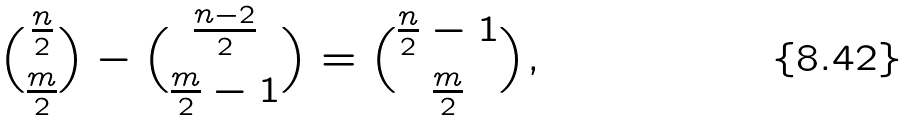<formula> <loc_0><loc_0><loc_500><loc_500>{ \frac { n } { 2 } \choose \frac { m } { 2 } } - { \frac { n - 2 } { 2 } \choose \frac { m } { 2 } - 1 } = { \frac { n } { 2 } - 1 \choose \frac { m } { 2 } } ,</formula> 